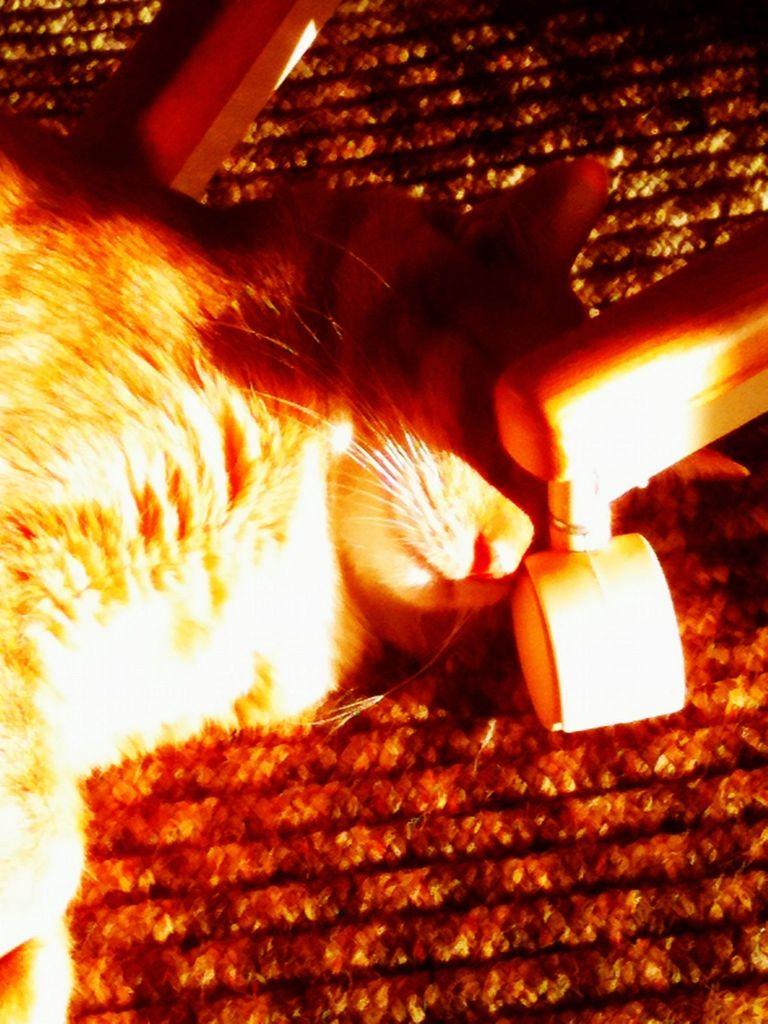What type of animal is in the image? There is a cat in the image. What is the cat laying on? The cat is laying on a mat. What else is visible near the cat? There is a wheel of a chair beside the cat. What flavor of rail can be seen in the image? There is no rail present in the image, and therefore no flavor can be associated with it. 